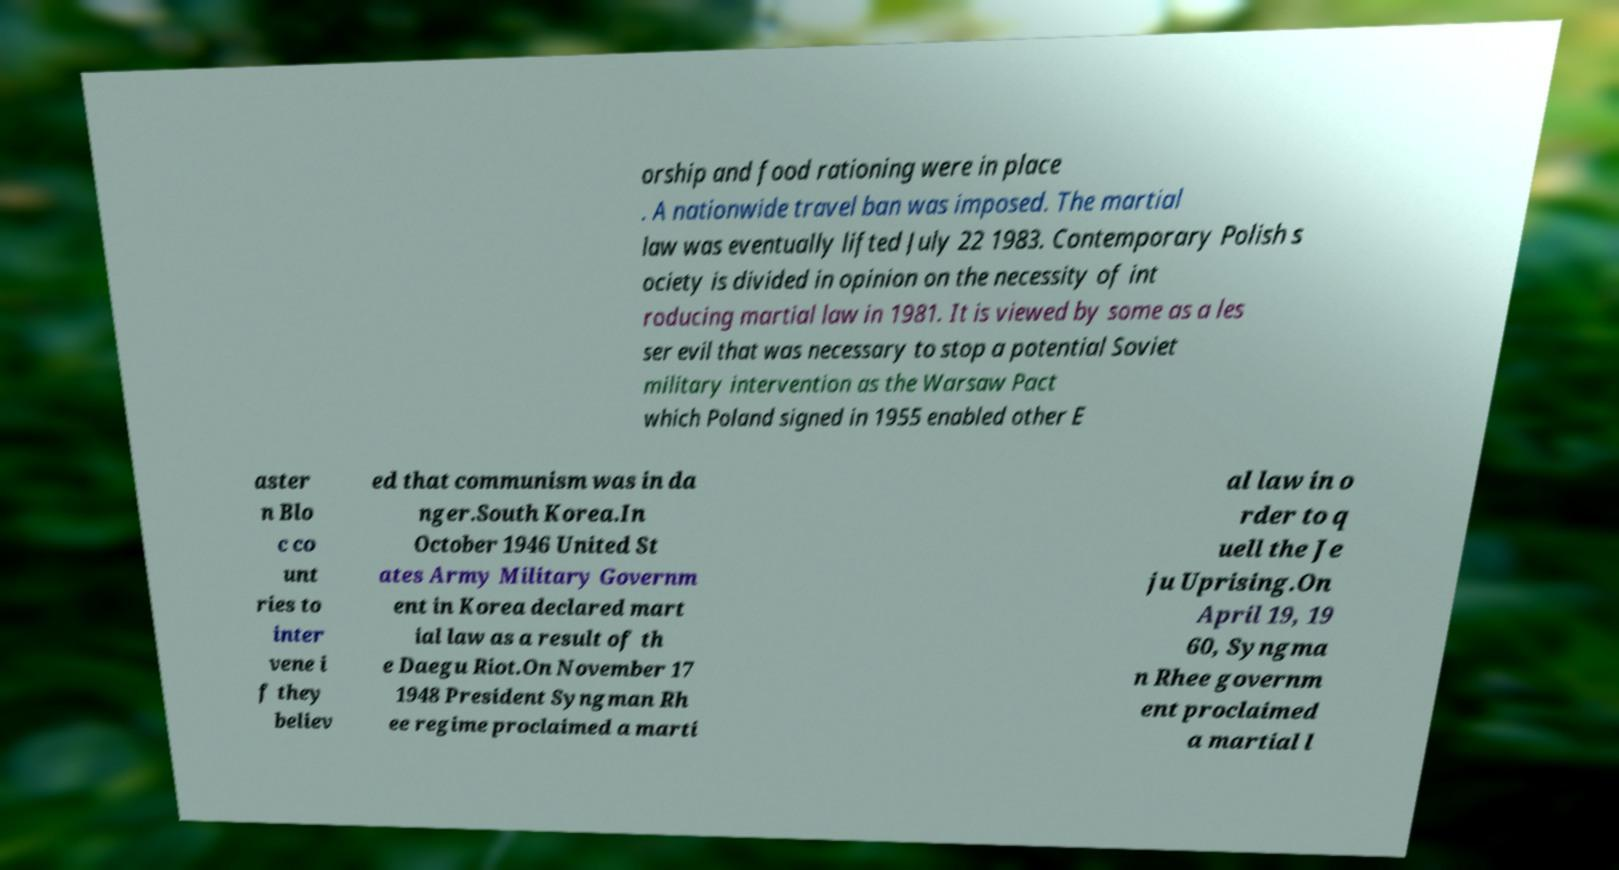Can you accurately transcribe the text from the provided image for me? orship and food rationing were in place . A nationwide travel ban was imposed. The martial law was eventually lifted July 22 1983. Contemporary Polish s ociety is divided in opinion on the necessity of int roducing martial law in 1981. It is viewed by some as a les ser evil that was necessary to stop a potential Soviet military intervention as the Warsaw Pact which Poland signed in 1955 enabled other E aster n Blo c co unt ries to inter vene i f they believ ed that communism was in da nger.South Korea.In October 1946 United St ates Army Military Governm ent in Korea declared mart ial law as a result of th e Daegu Riot.On November 17 1948 President Syngman Rh ee regime proclaimed a marti al law in o rder to q uell the Je ju Uprising.On April 19, 19 60, Syngma n Rhee governm ent proclaimed a martial l 